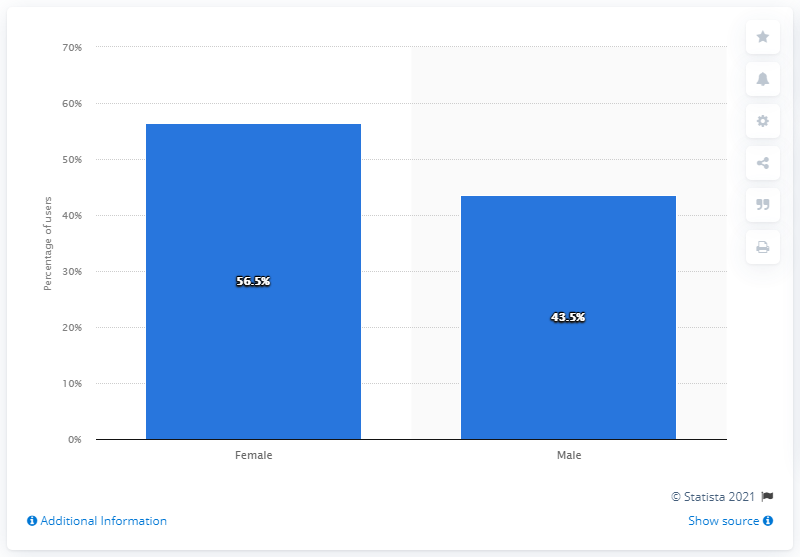Give some essential details in this illustration. As of April 2021, 56.5% of Instagram users in the United States were women. 